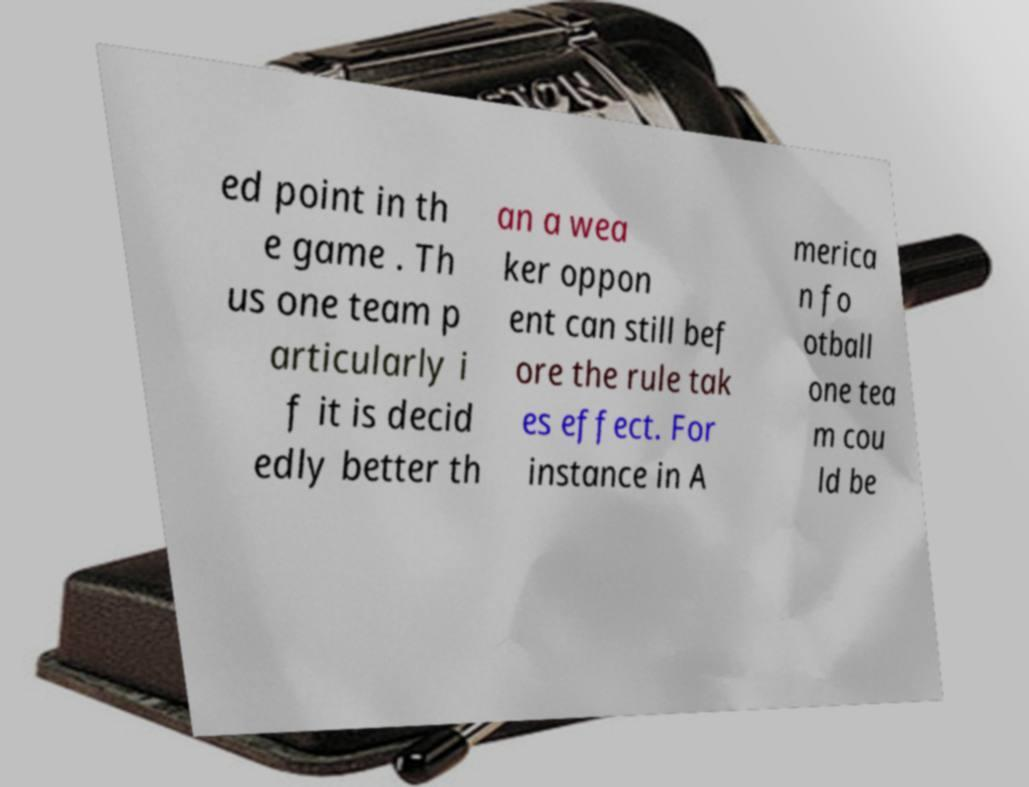Could you assist in decoding the text presented in this image and type it out clearly? ed point in th e game . Th us one team p articularly i f it is decid edly better th an a wea ker oppon ent can still bef ore the rule tak es effect. For instance in A merica n fo otball one tea m cou ld be 